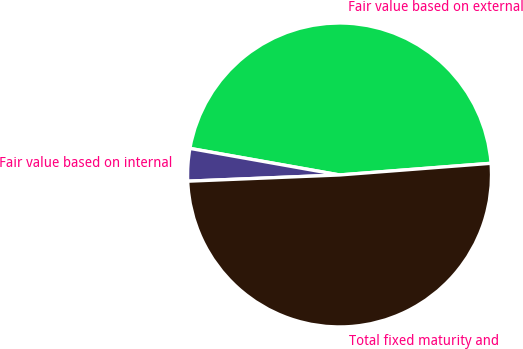<chart> <loc_0><loc_0><loc_500><loc_500><pie_chart><fcel>Fair value based on external<fcel>Fair value based on internal<fcel>Total fixed maturity and<nl><fcel>45.98%<fcel>3.45%<fcel>50.57%<nl></chart> 